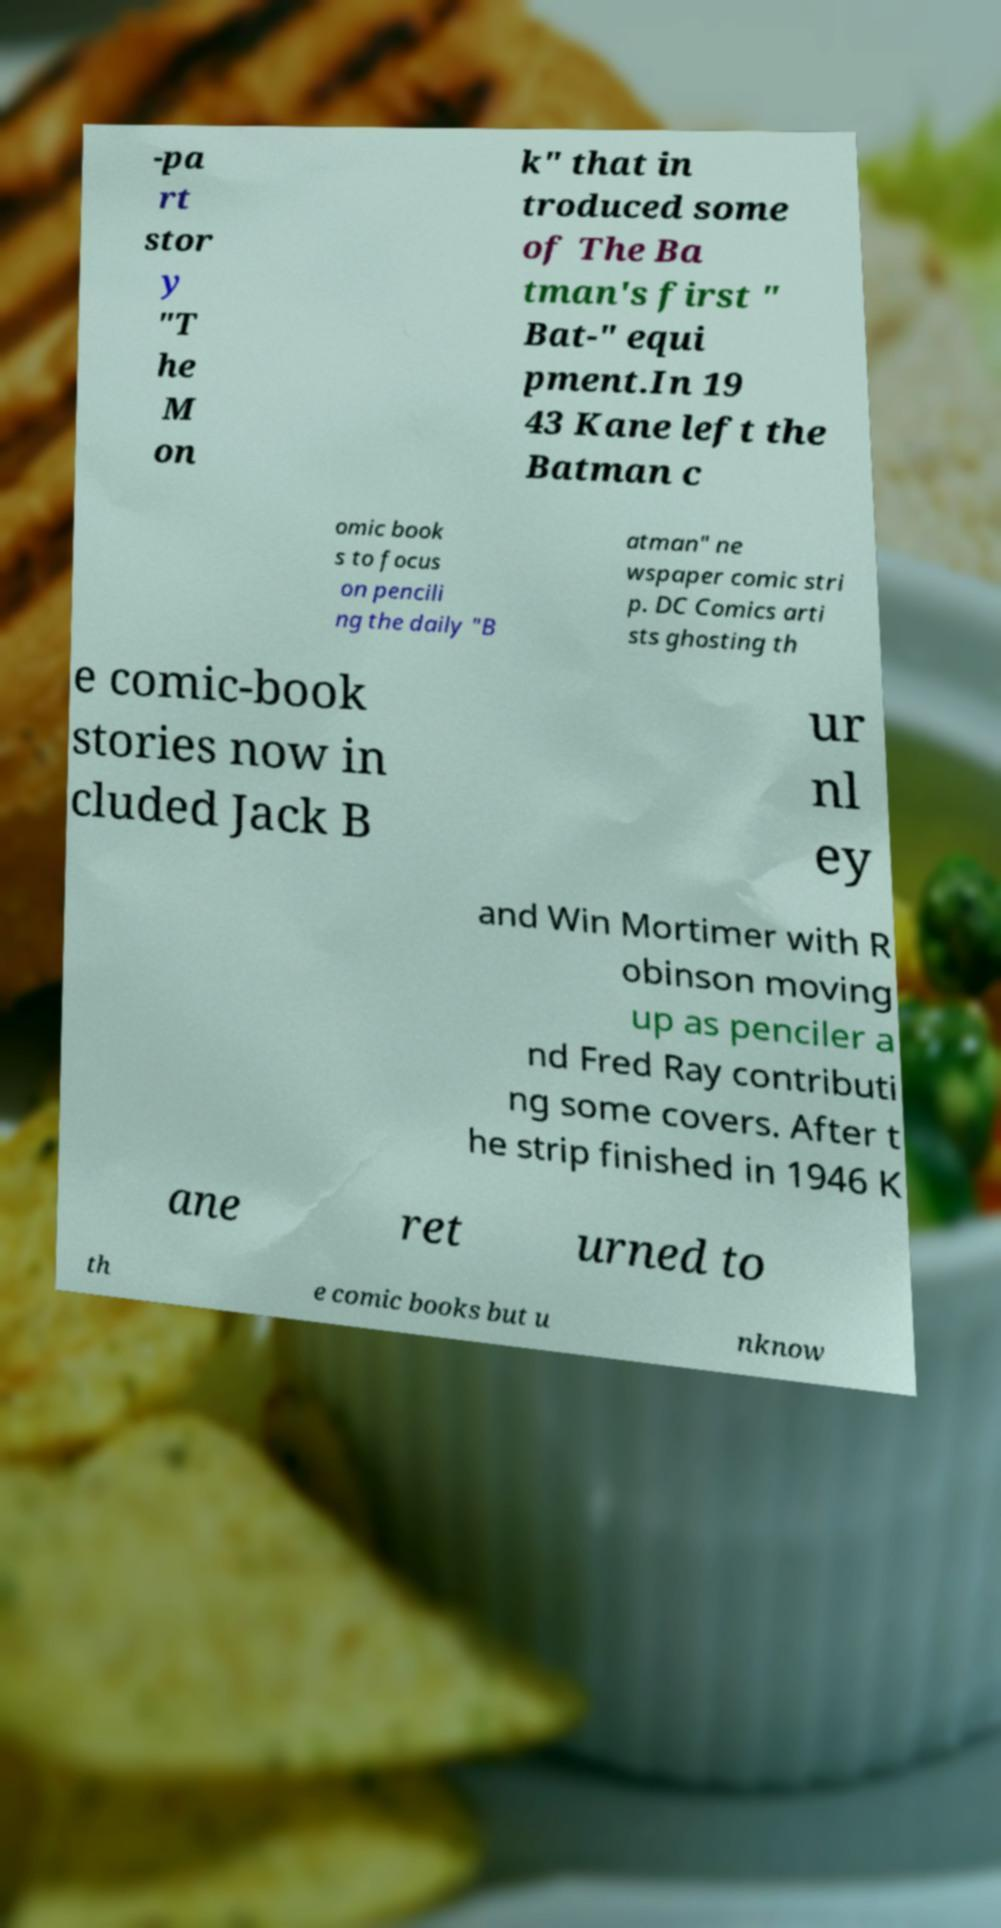There's text embedded in this image that I need extracted. Can you transcribe it verbatim? -pa rt stor y "T he M on k" that in troduced some of The Ba tman's first " Bat-" equi pment.In 19 43 Kane left the Batman c omic book s to focus on pencili ng the daily "B atman" ne wspaper comic stri p. DC Comics arti sts ghosting th e comic-book stories now in cluded Jack B ur nl ey and Win Mortimer with R obinson moving up as penciler a nd Fred Ray contributi ng some covers. After t he strip finished in 1946 K ane ret urned to th e comic books but u nknow 